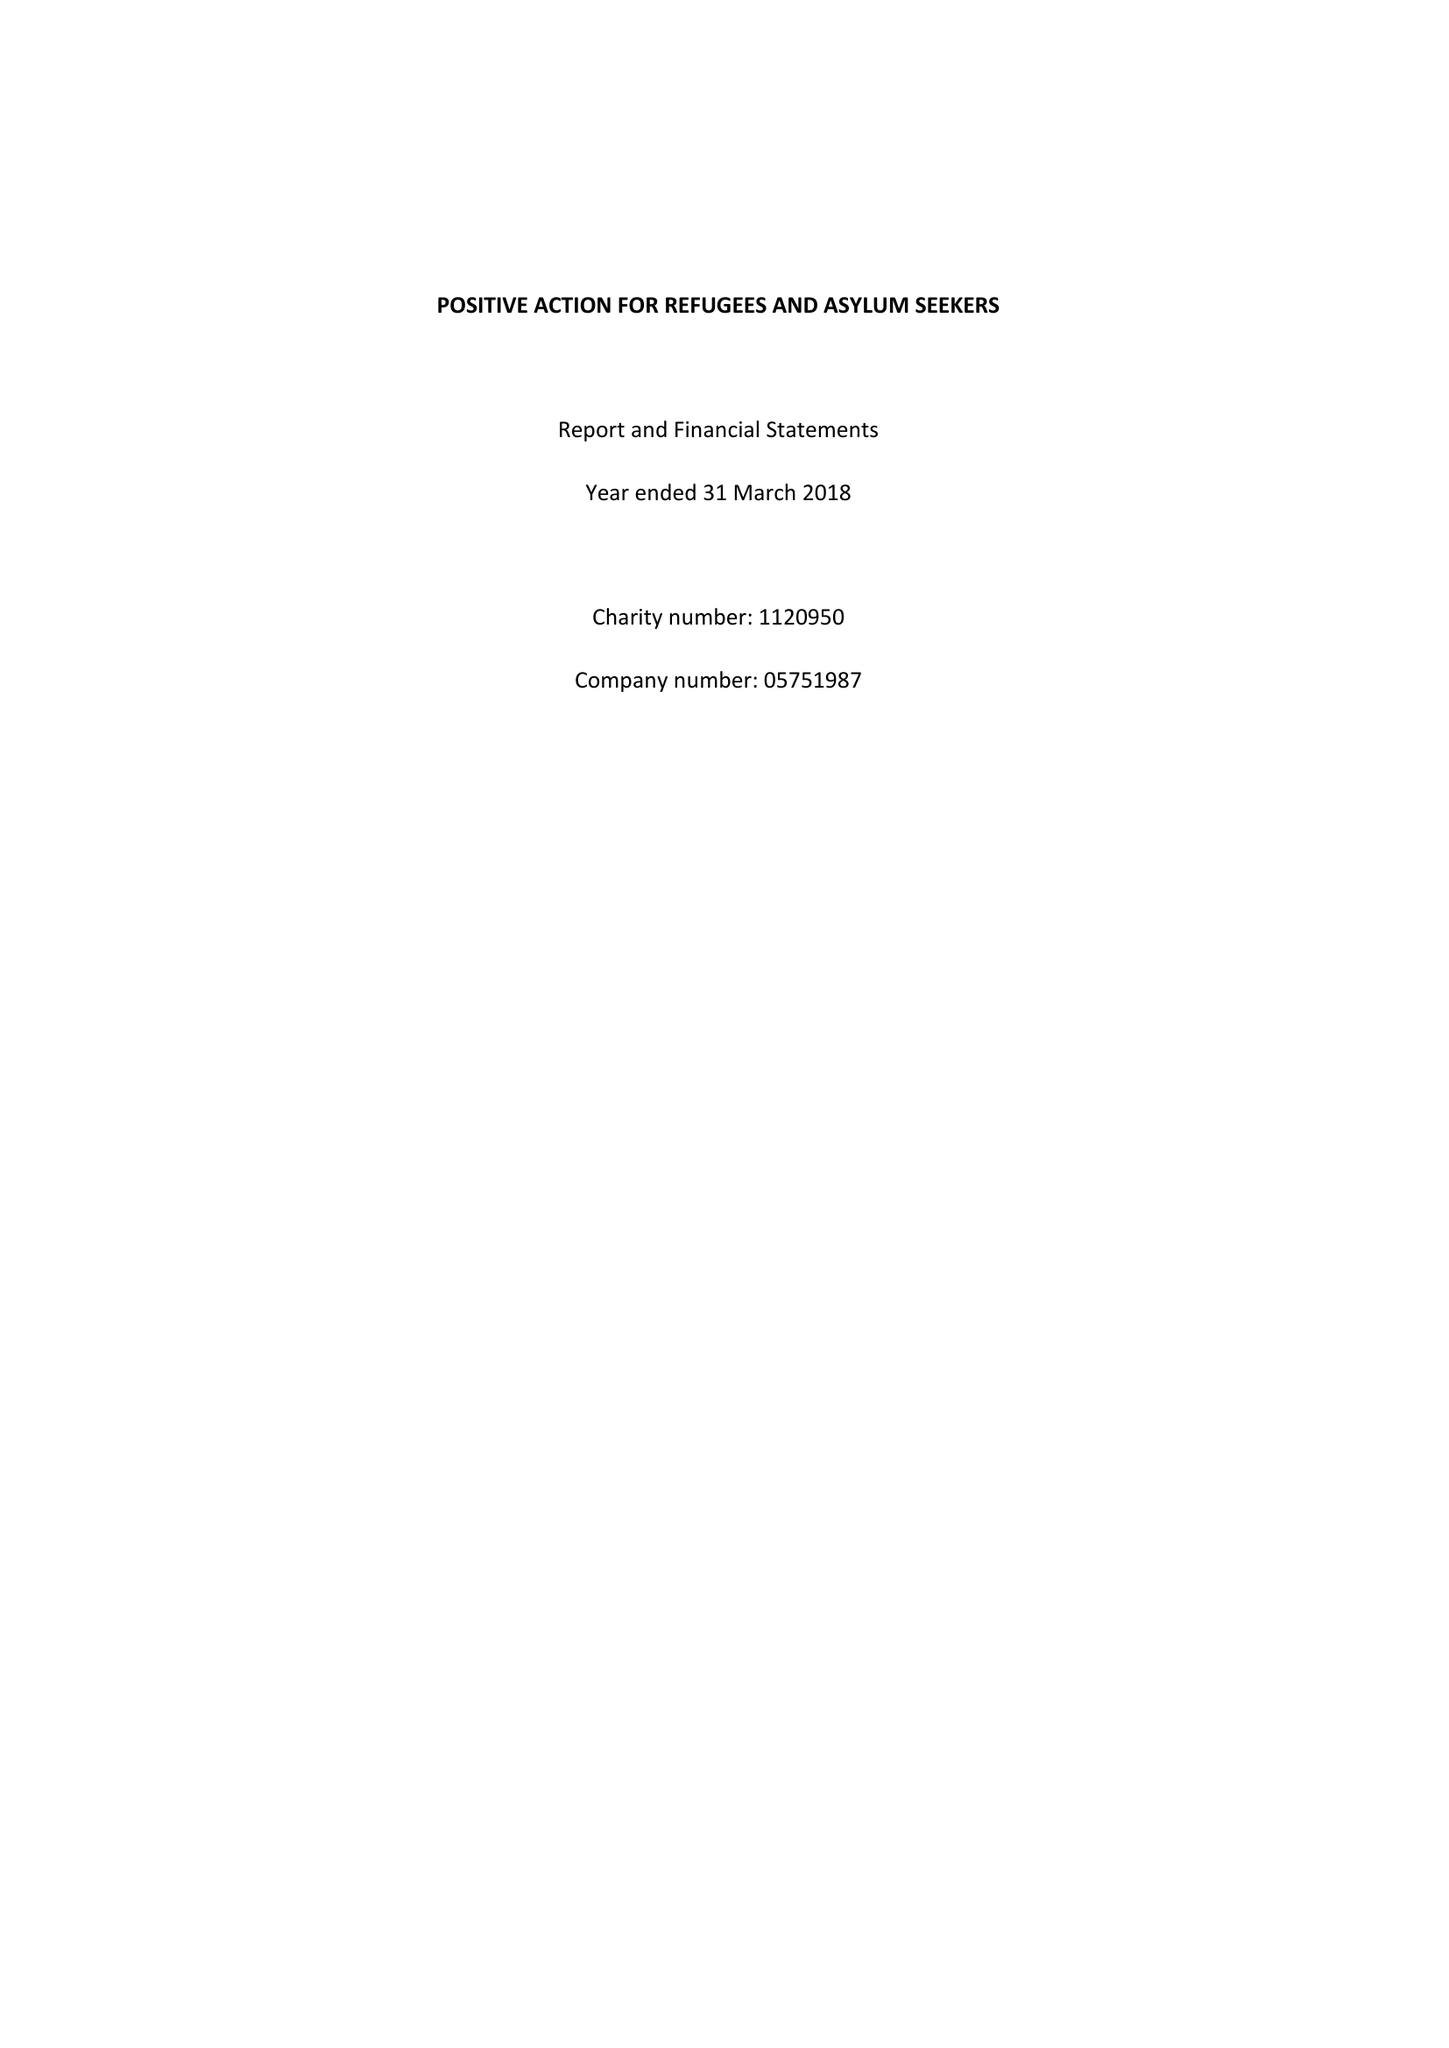What is the value for the address__post_town?
Answer the question using a single word or phrase. LEEDS 